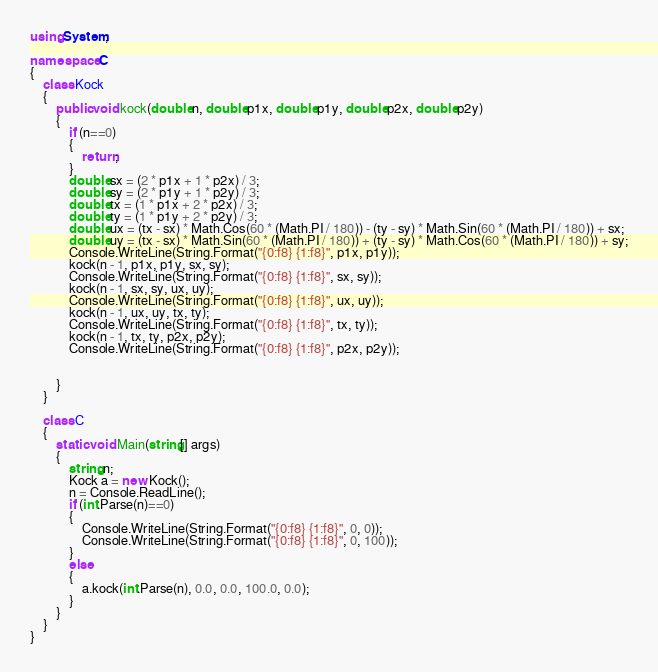<code> <loc_0><loc_0><loc_500><loc_500><_C#_>using System;

namespace C
{
    class Kock
    {
        public void kock(double n, double p1x, double p1y, double p2x, double p2y)
        {
            if (n==0)
            {
                return;
            }
            double sx = (2 * p1x + 1 * p2x) / 3;
            double sy = (2 * p1y + 1 * p2y) / 3;
            double tx = (1 * p1x + 2 * p2x) / 3;
            double ty = (1 * p1y + 2 * p2y) / 3;
            double ux = (tx - sx) * Math.Cos(60 * (Math.PI / 180)) - (ty - sy) * Math.Sin(60 * (Math.PI / 180)) + sx;
            double uy = (tx - sx) * Math.Sin(60 * (Math.PI / 180)) + (ty - sy) * Math.Cos(60 * (Math.PI / 180)) + sy;
            Console.WriteLine(String.Format("{0:f8} {1:f8}", p1x, p1y));
            kock(n - 1, p1x, p1y, sx, sy);
            Console.WriteLine(String.Format("{0:f8} {1:f8}", sx, sy));
            kock(n - 1, sx, sy, ux, uy);
            Console.WriteLine(String.Format("{0:f8} {1:f8}", ux, uy));
            kock(n - 1, ux, uy, tx, ty);
            Console.WriteLine(String.Format("{0:f8} {1:f8}", tx, ty));
            kock(n - 1, tx, ty, p2x, p2y);
            Console.WriteLine(String.Format("{0:f8} {1:f8}", p2x, p2y));
            

        }
    }

    class C
    {
        static void Main(string[] args)
        {
            string n;
            Kock a = new Kock();
            n = Console.ReadLine();
            if (int.Parse(n)==0)
            {
                Console.WriteLine(String.Format("{0:f8} {1:f8}", 0, 0));
                Console.WriteLine(String.Format("{0:f8} {1:f8}", 0, 100));
            }
            else
            {
                a.kock(int.Parse(n), 0.0, 0.0, 100.0, 0.0);
            }
        }
    }
}

</code> 